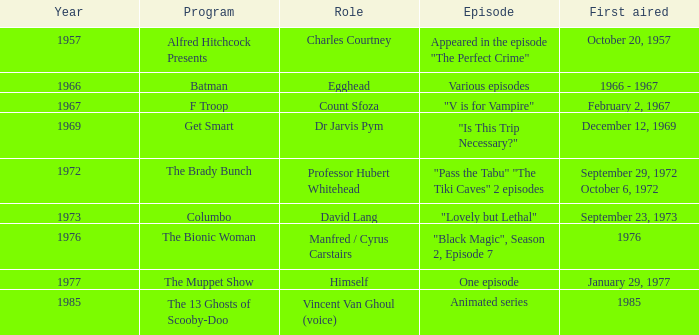Would you be able to parse every entry in this table? {'header': ['Year', 'Program', 'Role', 'Episode', 'First aired'], 'rows': [['1957', 'Alfred Hitchcock Presents', 'Charles Courtney', 'Appeared in the episode "The Perfect Crime"', 'October 20, 1957'], ['1966', 'Batman', 'Egghead', 'Various episodes', '1966 - 1967'], ['1967', 'F Troop', 'Count Sfoza', '"V is for Vampire"', 'February 2, 1967'], ['1969', 'Get Smart', 'Dr Jarvis Pym', '"Is This Trip Necessary?"', 'December 12, 1969'], ['1972', 'The Brady Bunch', 'Professor Hubert Whitehead', '"Pass the Tabu" "The Tiki Caves" 2 episodes', 'September 29, 1972 October 6, 1972'], ['1973', 'Columbo', 'David Lang', '"Lovely but Lethal"', 'September 23, 1973'], ['1976', 'The Bionic Woman', 'Manfred / Cyrus Carstairs', '"Black Magic", Season 2, Episode 7', '1976'], ['1977', 'The Muppet Show', 'Himself', 'One episode', 'January 29, 1977'], ['1985', 'The 13 Ghosts of Scooby-Doo', 'Vincent Van Ghoul (voice)', 'Animated series', '1985']]} What episode was first aired in 1976? "Black Magic", Season 2, Episode 7. 